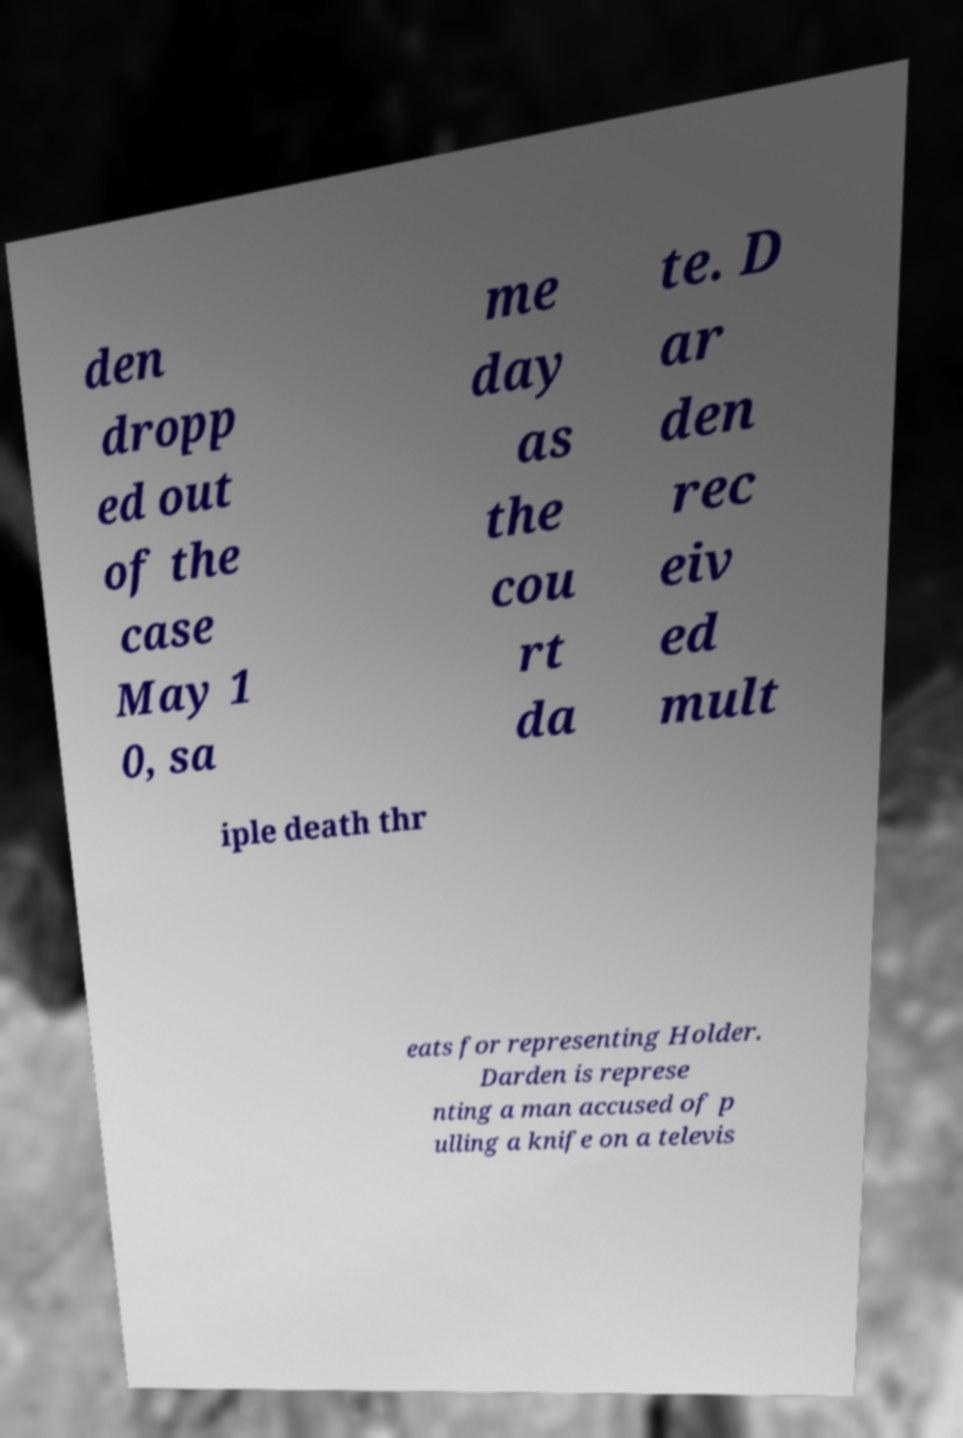Please read and relay the text visible in this image. What does it say? den dropp ed out of the case May 1 0, sa me day as the cou rt da te. D ar den rec eiv ed mult iple death thr eats for representing Holder. Darden is represe nting a man accused of p ulling a knife on a televis 